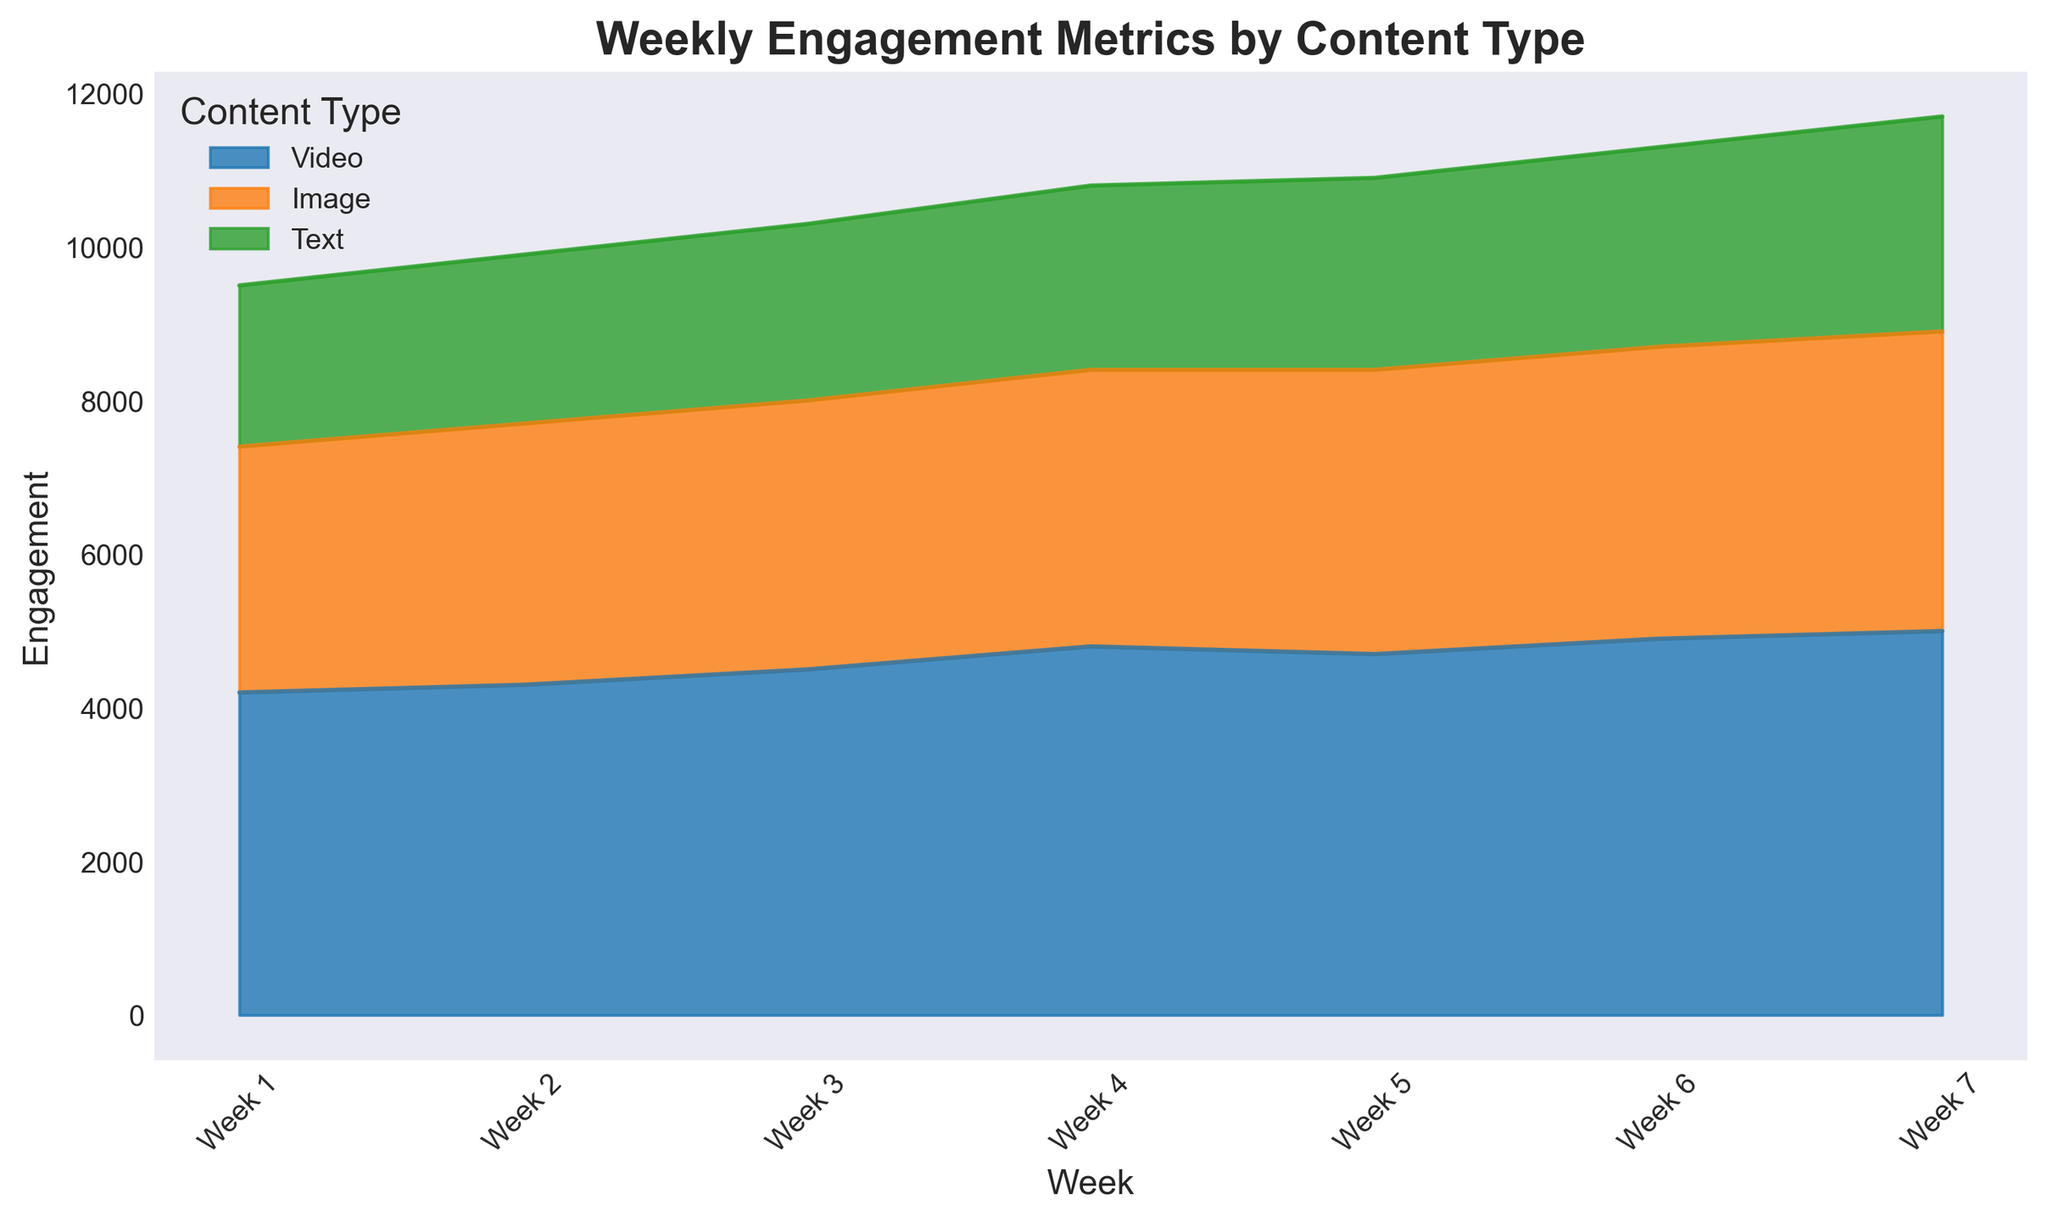What was the engagement for images in Week 4 and Week 5? By referring to the area attributed to images (usually shown in a distinct color), we see that the engagement values in Week 4 and Week 5 for images are marked.
Answer: 3600, 3700 Which content type showed the highest engagement by Week 7? To answer, observe the heights of the area chart for each content type in Week 7. The highest engagement value corresponds to the tallest area, which represents videos.
Answer: Videos Has the engagement for text content increased or decreased from Week 1 to Week 7? We check the area assigned to text content over Weeks 1 to 7. The height increases gradually across these weeks, indicating an increase in engagement.
Answer: Increased What's the total engagement for videos from Week 1 to Week 3? Sum the engagement values for videos in Week 1 (4200), Week 2 (4300), and Week 3 (4500): 4200+4300+4500.
Answer: 13000 Compare the engagement for videos and images in Week 5. Which one has higher engagement? Observe the height of the areas for videos and images in Week 5. Video engagement (4700) is higher than image engagement (3700).
Answer: Videos Considering Week 6, by how much did video engagement surpass text engagement? Subtract text engagement in Week 6 (2600) from video engagement in Week 6 (4900): 4900 - 2600.
Answer: 2300 What is the average weekly engagement for text content over the 7 weeks? Add up the weekly engagement values for text content: 2100+2200+2300+2400+2500+2600+2800 and divide by 7: (2100+2200+2300+2400+2500+2600+2800)/7.
Answer: 2414.3 Comparing the trends, which content type shows the most consistent weekly growth? Videos' and images' areas consistently increase each week, while engagement for text content fluctuates. Videos show the most consistent growth.
Answer: Videos 